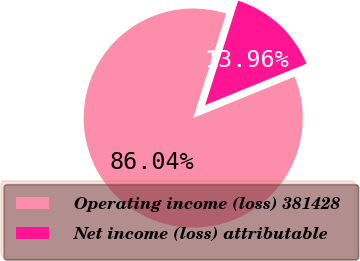Convert chart. <chart><loc_0><loc_0><loc_500><loc_500><pie_chart><fcel>Operating income (loss) 381428<fcel>Net income (loss) attributable<nl><fcel>86.04%<fcel>13.96%<nl></chart> 